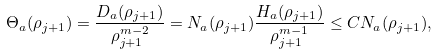<formula> <loc_0><loc_0><loc_500><loc_500>\Theta _ { a } ( \rho _ { j + 1 } ) = \frac { D _ { a } ( \rho _ { j + 1 } ) } { \rho _ { j + 1 } ^ { m - 2 } } = N _ { a } ( \rho _ { j + 1 } ) \frac { H _ { a } ( \rho _ { j + 1 } ) } { \rho _ { j + 1 } ^ { m - 1 } } \leq C N _ { a } ( \rho _ { j + 1 } ) ,</formula> 